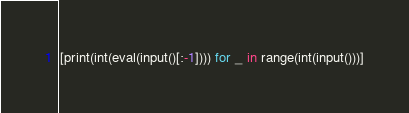Convert code to text. <code><loc_0><loc_0><loc_500><loc_500><_Python_>[print(int(eval(input()[:-1]))) for _ in range(int(input()))]

</code> 